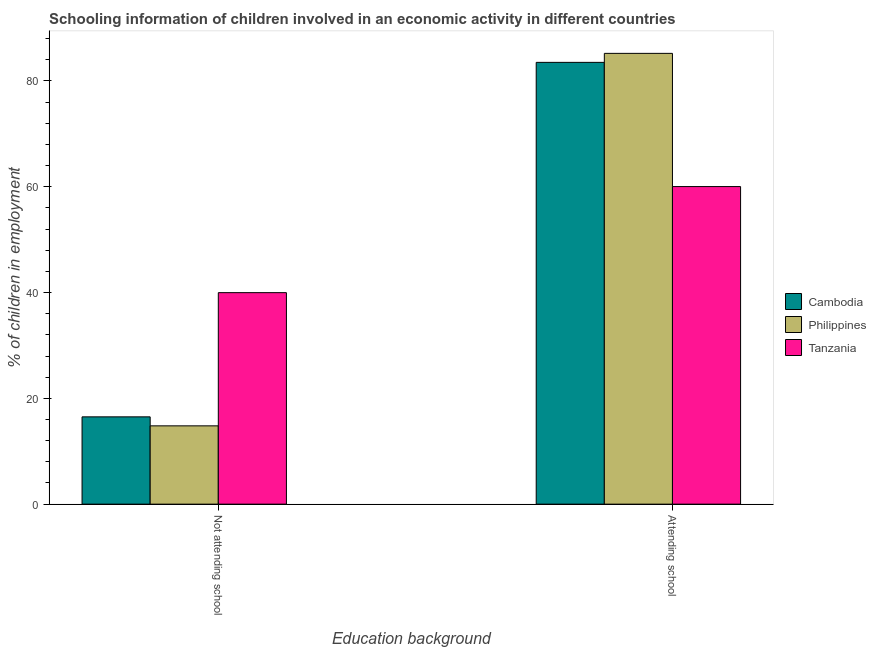How many different coloured bars are there?
Keep it short and to the point. 3. Are the number of bars per tick equal to the number of legend labels?
Your response must be concise. Yes. How many bars are there on the 2nd tick from the left?
Ensure brevity in your answer.  3. What is the label of the 2nd group of bars from the left?
Your answer should be compact. Attending school. What is the percentage of employed children who are not attending school in Philippines?
Provide a short and direct response. 14.8. Across all countries, what is the maximum percentage of employed children who are not attending school?
Ensure brevity in your answer.  39.98. Across all countries, what is the minimum percentage of employed children who are not attending school?
Your answer should be compact. 14.8. In which country was the percentage of employed children who are attending school maximum?
Your answer should be very brief. Philippines. In which country was the percentage of employed children who are not attending school minimum?
Offer a very short reply. Philippines. What is the total percentage of employed children who are attending school in the graph?
Provide a succinct answer. 228.73. What is the difference between the percentage of employed children who are attending school in Tanzania and that in Cambodia?
Ensure brevity in your answer.  -23.48. What is the difference between the percentage of employed children who are not attending school in Tanzania and the percentage of employed children who are attending school in Cambodia?
Your answer should be compact. -43.52. What is the average percentage of employed children who are attending school per country?
Ensure brevity in your answer.  76.24. What is the difference between the percentage of employed children who are not attending school and percentage of employed children who are attending school in Philippines?
Keep it short and to the point. -70.4. What is the ratio of the percentage of employed children who are not attending school in Tanzania to that in Cambodia?
Ensure brevity in your answer.  2.42. What does the 3rd bar from the right in Not attending school represents?
Your answer should be compact. Cambodia. How many bars are there?
Provide a succinct answer. 6. How many countries are there in the graph?
Keep it short and to the point. 3. Are the values on the major ticks of Y-axis written in scientific E-notation?
Your response must be concise. No. Does the graph contain any zero values?
Give a very brief answer. No. How are the legend labels stacked?
Your response must be concise. Vertical. What is the title of the graph?
Your answer should be very brief. Schooling information of children involved in an economic activity in different countries. What is the label or title of the X-axis?
Give a very brief answer. Education background. What is the label or title of the Y-axis?
Make the answer very short. % of children in employment. What is the % of children in employment in Philippines in Not attending school?
Your answer should be very brief. 14.8. What is the % of children in employment of Tanzania in Not attending school?
Keep it short and to the point. 39.98. What is the % of children in employment in Cambodia in Attending school?
Your answer should be very brief. 83.5. What is the % of children in employment in Philippines in Attending school?
Your response must be concise. 85.2. What is the % of children in employment of Tanzania in Attending school?
Keep it short and to the point. 60.02. Across all Education background, what is the maximum % of children in employment in Cambodia?
Offer a terse response. 83.5. Across all Education background, what is the maximum % of children in employment in Philippines?
Ensure brevity in your answer.  85.2. Across all Education background, what is the maximum % of children in employment in Tanzania?
Your response must be concise. 60.02. Across all Education background, what is the minimum % of children in employment of Philippines?
Your answer should be very brief. 14.8. Across all Education background, what is the minimum % of children in employment in Tanzania?
Your answer should be compact. 39.98. What is the total % of children in employment in Philippines in the graph?
Offer a terse response. 100. What is the difference between the % of children in employment in Cambodia in Not attending school and that in Attending school?
Your answer should be compact. -67. What is the difference between the % of children in employment in Philippines in Not attending school and that in Attending school?
Provide a succinct answer. -70.4. What is the difference between the % of children in employment in Tanzania in Not attending school and that in Attending school?
Provide a succinct answer. -20.05. What is the difference between the % of children in employment of Cambodia in Not attending school and the % of children in employment of Philippines in Attending school?
Ensure brevity in your answer.  -68.7. What is the difference between the % of children in employment of Cambodia in Not attending school and the % of children in employment of Tanzania in Attending school?
Offer a very short reply. -43.52. What is the difference between the % of children in employment in Philippines in Not attending school and the % of children in employment in Tanzania in Attending school?
Ensure brevity in your answer.  -45.23. What is the average % of children in employment of Philippines per Education background?
Your response must be concise. 50. What is the difference between the % of children in employment in Cambodia and % of children in employment in Philippines in Not attending school?
Provide a succinct answer. 1.7. What is the difference between the % of children in employment in Cambodia and % of children in employment in Tanzania in Not attending school?
Provide a short and direct response. -23.48. What is the difference between the % of children in employment in Philippines and % of children in employment in Tanzania in Not attending school?
Your answer should be compact. -25.18. What is the difference between the % of children in employment of Cambodia and % of children in employment of Philippines in Attending school?
Make the answer very short. -1.7. What is the difference between the % of children in employment of Cambodia and % of children in employment of Tanzania in Attending school?
Ensure brevity in your answer.  23.48. What is the difference between the % of children in employment of Philippines and % of children in employment of Tanzania in Attending school?
Your response must be concise. 25.18. What is the ratio of the % of children in employment of Cambodia in Not attending school to that in Attending school?
Your response must be concise. 0.2. What is the ratio of the % of children in employment in Philippines in Not attending school to that in Attending school?
Your answer should be compact. 0.17. What is the ratio of the % of children in employment in Tanzania in Not attending school to that in Attending school?
Ensure brevity in your answer.  0.67. What is the difference between the highest and the second highest % of children in employment of Philippines?
Provide a succinct answer. 70.4. What is the difference between the highest and the second highest % of children in employment in Tanzania?
Give a very brief answer. 20.05. What is the difference between the highest and the lowest % of children in employment of Philippines?
Offer a very short reply. 70.4. What is the difference between the highest and the lowest % of children in employment of Tanzania?
Offer a very short reply. 20.05. 